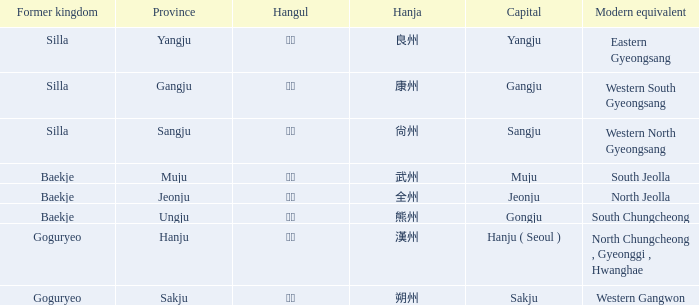Can you parse all the data within this table? {'header': ['Former kingdom', 'Province', 'Hangul', 'Hanja', 'Capital', 'Modern equivalent'], 'rows': [['Silla', 'Yangju', '양주', '良州', 'Yangju', 'Eastern Gyeongsang'], ['Silla', 'Gangju', '강주', '康州', 'Gangju', 'Western South Gyeongsang'], ['Silla', 'Sangju', '상주', '尙州', 'Sangju', 'Western North Gyeongsang'], ['Baekje', 'Muju', '무주', '武州', 'Muju', 'South Jeolla'], ['Baekje', 'Jeonju', '전주', '全州', 'Jeonju', 'North Jeolla'], ['Baekje', 'Ungju', '웅주', '熊州', 'Gongju', 'South Chungcheong'], ['Goguryeo', 'Hanju', '한주', '漢州', 'Hanju ( Seoul )', 'North Chungcheong , Gyeonggi , Hwanghae'], ['Goguryeo', 'Sakju', '삭주', '朔州', 'Sakju', 'Western Gangwon']]} What are the modern equivalents for the province of "hanju"? North Chungcheong , Gyeonggi , Hwanghae. 